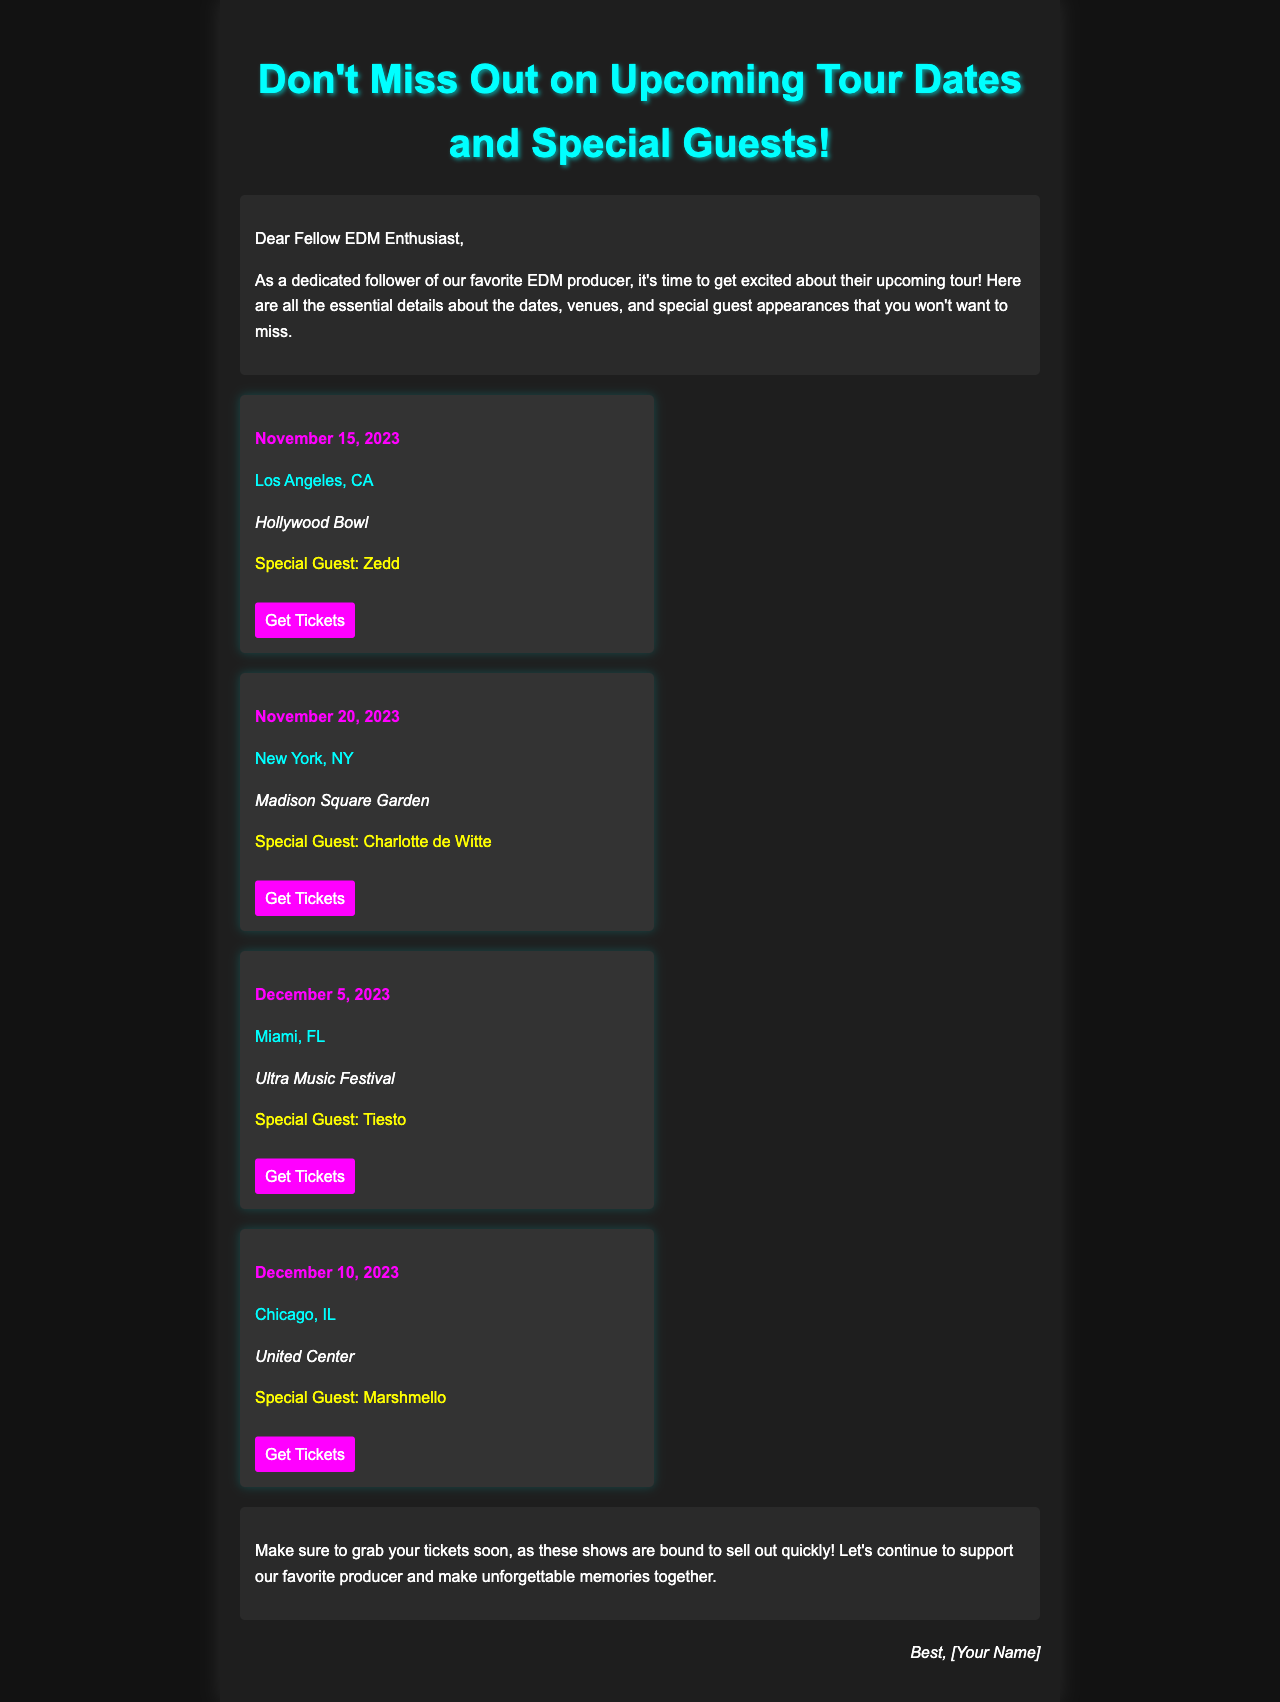What is the date of the Los Angeles show? The date of the Los Angeles show is mentioned in the document as November 15, 2023.
Answer: November 15, 2023 Who is the special guest for the New York concert? The special guest for the New York concert is listed as Charlotte de Witte in the document.
Answer: Charlotte de Witte What venue will host the Miami show? The venue for the Miami show is found in the document as Ultra Music Festival.
Answer: Ultra Music Festival How many total tour dates are listed in the document? The document contains four tour dates as detailed in the tour sections.
Answer: 4 Which city is the last tour date scheduled in? The last tour date is mentioned to take place in Chicago, IL.
Answer: Chicago, IL What color are the concert date headers? The concert date headers are presented in the document with the color magenta.
Answer: Magenta What type of information is included in the closing section? The closing section shares encouragement and advises to purchase tickets as they will sell out.
Answer: Encouragement and ticket purchase advice What should fans do soon according to the closing paragraph? According to the closing paragraph, fans should grab their tickets soon.
Answer: Grab tickets soon 